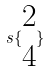<formula> <loc_0><loc_0><loc_500><loc_500>s \{ \begin{matrix} 2 \\ 4 \end{matrix} \}</formula> 